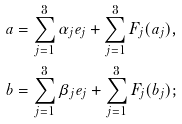Convert formula to latex. <formula><loc_0><loc_0><loc_500><loc_500>a & = \sum _ { j = 1 } ^ { 3 } \alpha _ { j } e _ { j } + \sum _ { j = 1 } ^ { 3 } F _ { j } ( a _ { j } ) , \\ b & = \sum _ { j = 1 } ^ { 3 } \beta _ { j } e _ { j } + \sum _ { j = 1 } ^ { 3 } F _ { j } ( b _ { j } ) ;</formula> 